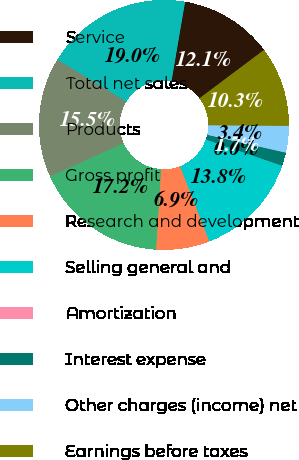<chart> <loc_0><loc_0><loc_500><loc_500><pie_chart><fcel>Service<fcel>Total net sales<fcel>Products<fcel>Gross profit<fcel>Research and development<fcel>Selling general and<fcel>Amortization<fcel>Interest expense<fcel>Other charges (income) net<fcel>Earnings before taxes<nl><fcel>12.07%<fcel>18.96%<fcel>15.51%<fcel>17.24%<fcel>6.9%<fcel>13.79%<fcel>0.01%<fcel>1.73%<fcel>3.45%<fcel>10.34%<nl></chart> 